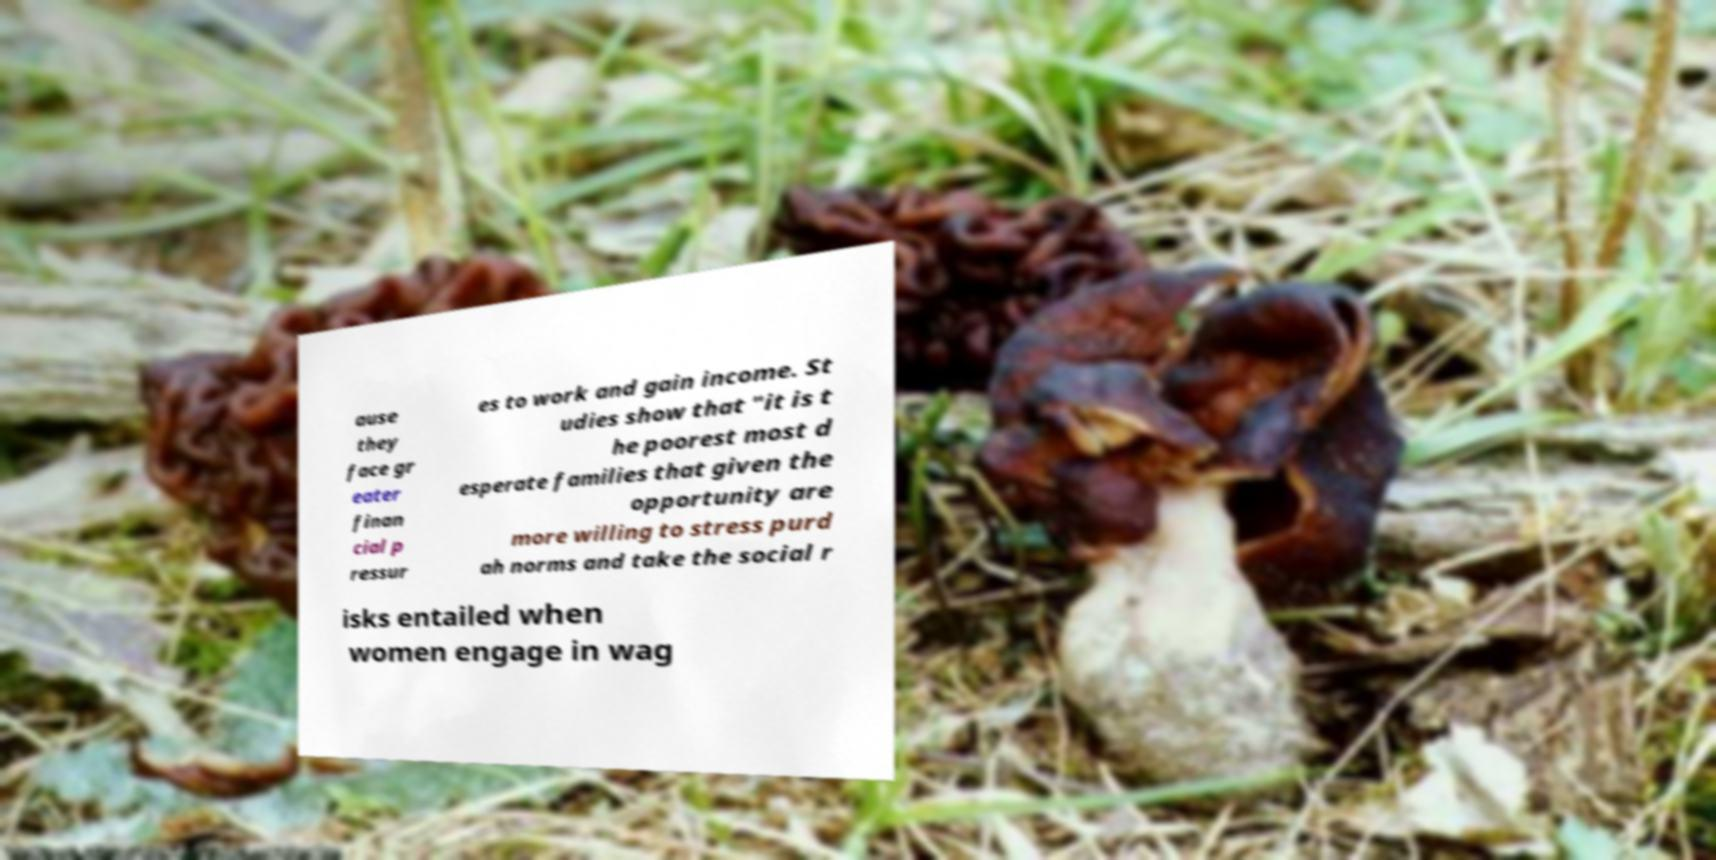Please identify and transcribe the text found in this image. ause they face gr eater finan cial p ressur es to work and gain income. St udies show that "it is t he poorest most d esperate families that given the opportunity are more willing to stress purd ah norms and take the social r isks entailed when women engage in wag 